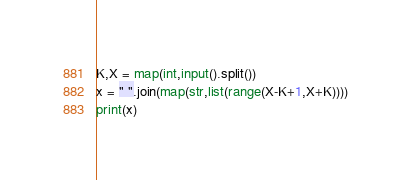Convert code to text. <code><loc_0><loc_0><loc_500><loc_500><_Python_>K,X = map(int,input().split())
x = " ".join(map(str,list(range(X-K+1,X+K))))
print(x)
</code> 